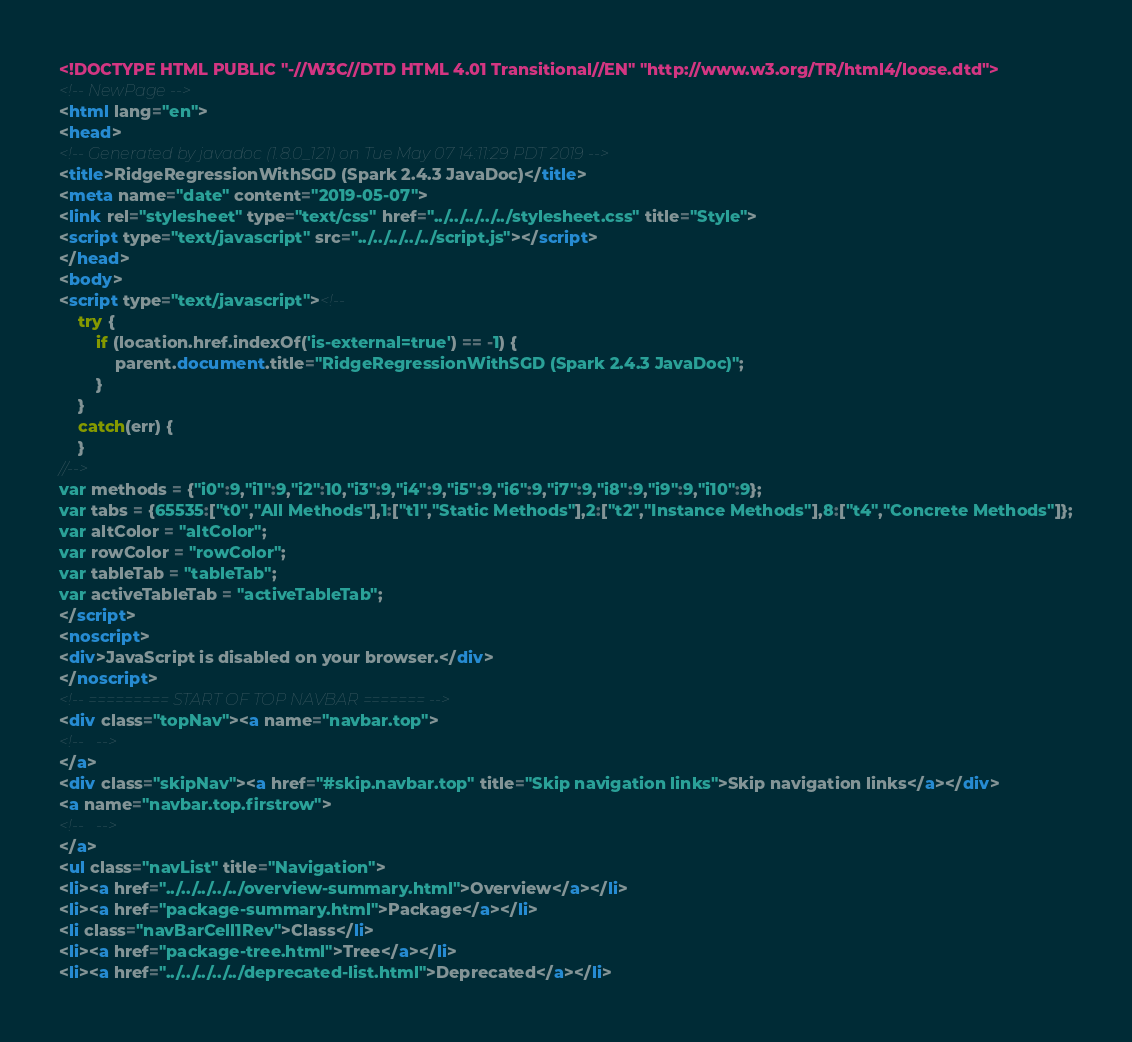<code> <loc_0><loc_0><loc_500><loc_500><_HTML_><!DOCTYPE HTML PUBLIC "-//W3C//DTD HTML 4.01 Transitional//EN" "http://www.w3.org/TR/html4/loose.dtd">
<!-- NewPage -->
<html lang="en">
<head>
<!-- Generated by javadoc (1.8.0_121) on Tue May 07 14:11:29 PDT 2019 -->
<title>RidgeRegressionWithSGD (Spark 2.4.3 JavaDoc)</title>
<meta name="date" content="2019-05-07">
<link rel="stylesheet" type="text/css" href="../../../../../stylesheet.css" title="Style">
<script type="text/javascript" src="../../../../../script.js"></script>
</head>
<body>
<script type="text/javascript"><!--
    try {
        if (location.href.indexOf('is-external=true') == -1) {
            parent.document.title="RidgeRegressionWithSGD (Spark 2.4.3 JavaDoc)";
        }
    }
    catch(err) {
    }
//-->
var methods = {"i0":9,"i1":9,"i2":10,"i3":9,"i4":9,"i5":9,"i6":9,"i7":9,"i8":9,"i9":9,"i10":9};
var tabs = {65535:["t0","All Methods"],1:["t1","Static Methods"],2:["t2","Instance Methods"],8:["t4","Concrete Methods"]};
var altColor = "altColor";
var rowColor = "rowColor";
var tableTab = "tableTab";
var activeTableTab = "activeTableTab";
</script>
<noscript>
<div>JavaScript is disabled on your browser.</div>
</noscript>
<!-- ========= START OF TOP NAVBAR ======= -->
<div class="topNav"><a name="navbar.top">
<!--   -->
</a>
<div class="skipNav"><a href="#skip.navbar.top" title="Skip navigation links">Skip navigation links</a></div>
<a name="navbar.top.firstrow">
<!--   -->
</a>
<ul class="navList" title="Navigation">
<li><a href="../../../../../overview-summary.html">Overview</a></li>
<li><a href="package-summary.html">Package</a></li>
<li class="navBarCell1Rev">Class</li>
<li><a href="package-tree.html">Tree</a></li>
<li><a href="../../../../../deprecated-list.html">Deprecated</a></li></code> 